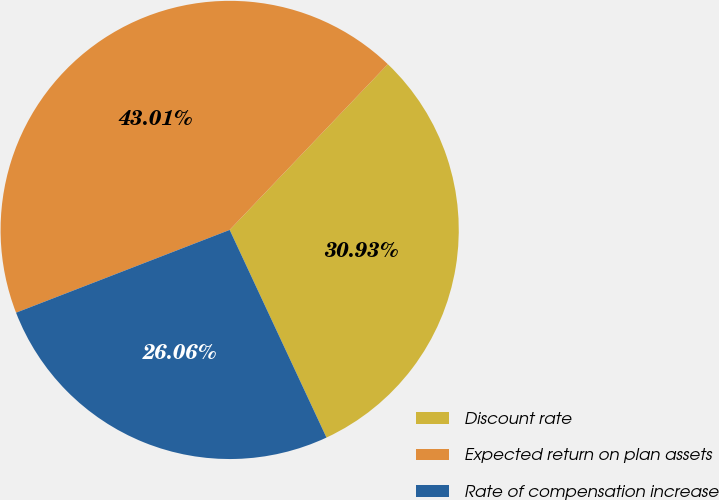Convert chart. <chart><loc_0><loc_0><loc_500><loc_500><pie_chart><fcel>Discount rate<fcel>Expected return on plan assets<fcel>Rate of compensation increase<nl><fcel>30.93%<fcel>43.01%<fcel>26.06%<nl></chart> 